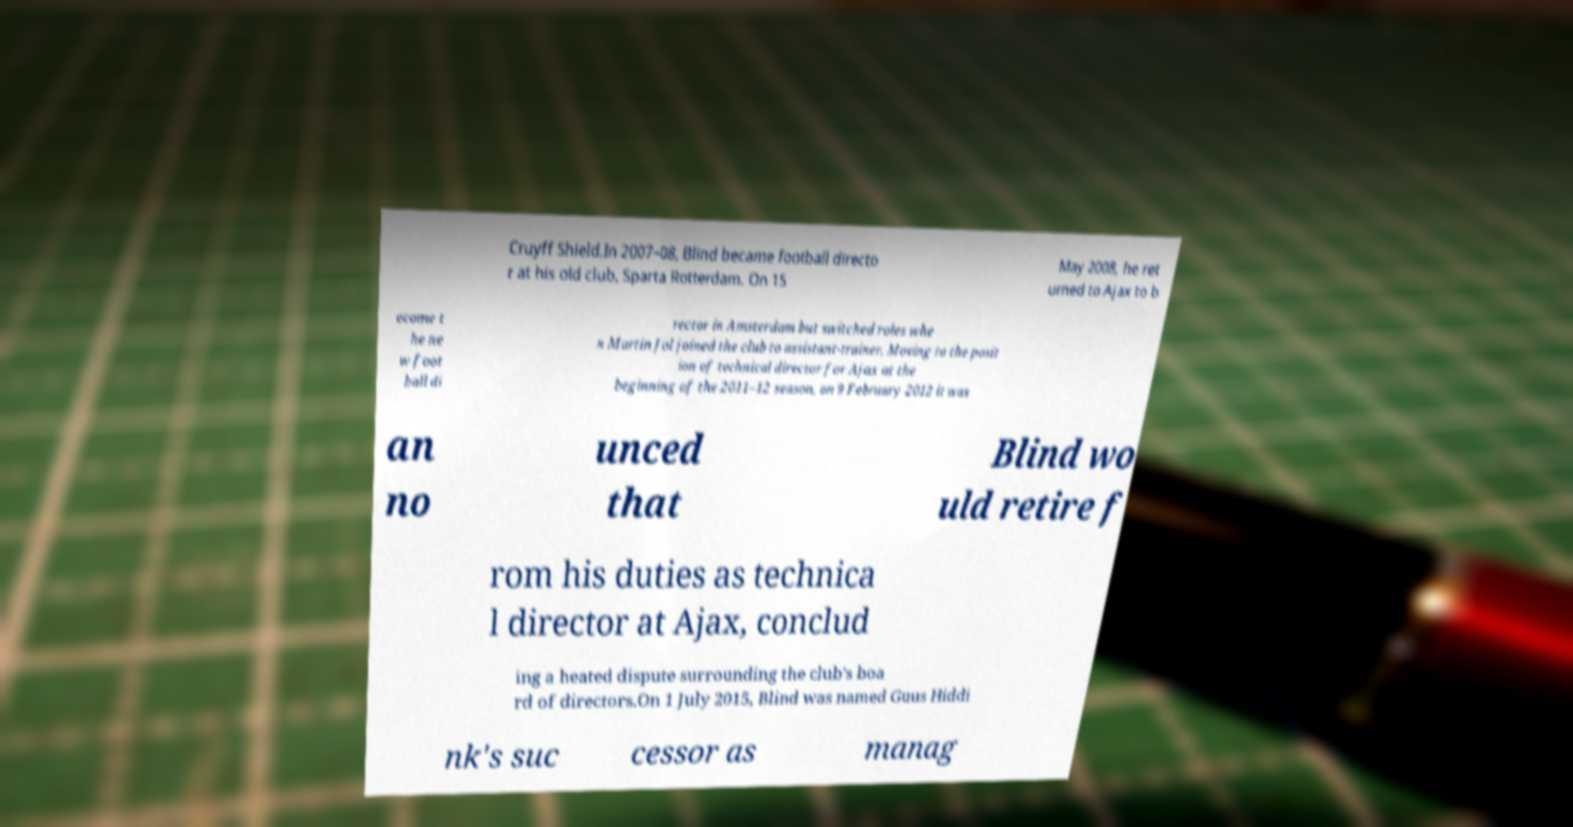For documentation purposes, I need the text within this image transcribed. Could you provide that? Cruyff Shield.In 2007–08, Blind became football directo r at his old club, Sparta Rotterdam. On 15 May 2008, he ret urned to Ajax to b ecome t he ne w foot ball di rector in Amsterdam but switched roles whe n Martin Jol joined the club to assistant-trainer. Moving to the posit ion of technical director for Ajax at the beginning of the 2011–12 season, on 9 February 2012 it was an no unced that Blind wo uld retire f rom his duties as technica l director at Ajax, conclud ing a heated dispute surrounding the club's boa rd of directors.On 1 July 2015, Blind was named Guus Hiddi nk's suc cessor as manag 